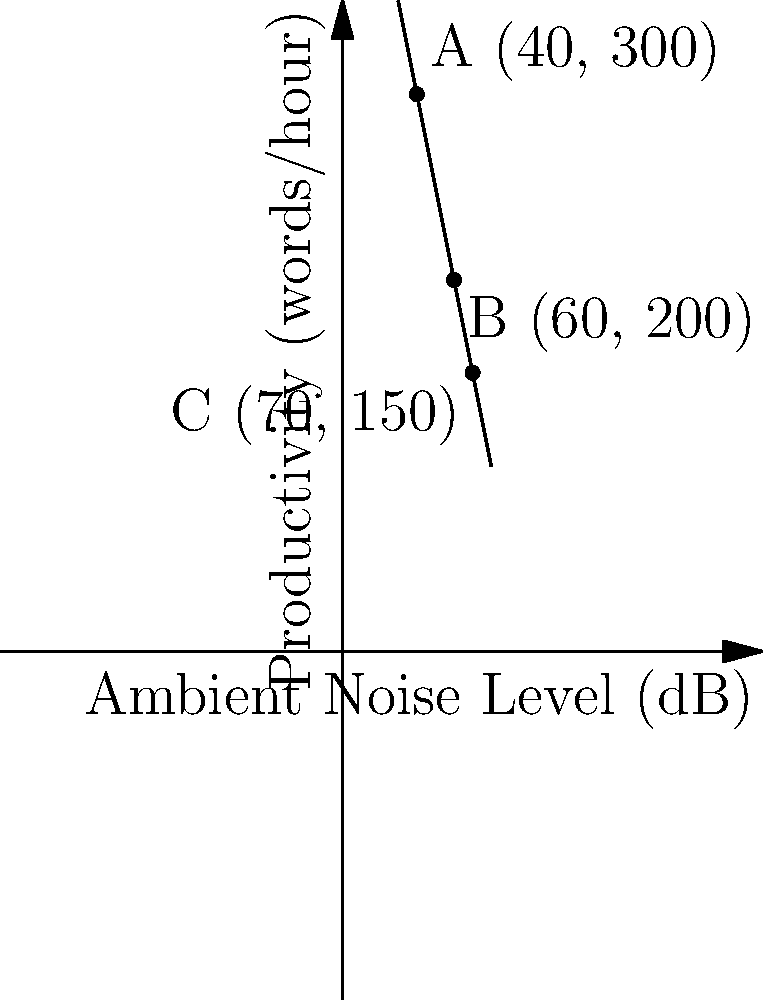An author's productivity is inversely related to the ambient noise level in his writing environment. The graph shows the relationship between the ambient noise level (in decibels) and the author's productivity (in words per hour). If the trend continues linearly, at what ambient noise level (in dB) would the author's productivity reach zero? To solve this problem, we need to follow these steps:

1) First, we need to determine the equation of the line. We can use two points to do this. Let's use points A(40, 300) and C(70, 150).

2) The slope of the line can be calculated using the formula:
   $m = \frac{y_2 - y_1}{x_2 - x_1} = \frac{150 - 300}{70 - 40} = -5$

3) Now we can use the point-slope form of a line equation:
   $y - y_1 = m(x - x_1)$
   $y - 300 = -5(x - 40)$

4) Simplify to get the equation in slope-intercept form:
   $y = -5x + 500$

5) To find where productivity reaches zero, set $y = 0$:
   $0 = -5x + 500$

6) Solve for x:
   $5x = 500$
   $x = 100$

Therefore, at 100 dB, the author's productivity would theoretically reach zero.
Answer: 100 dB 